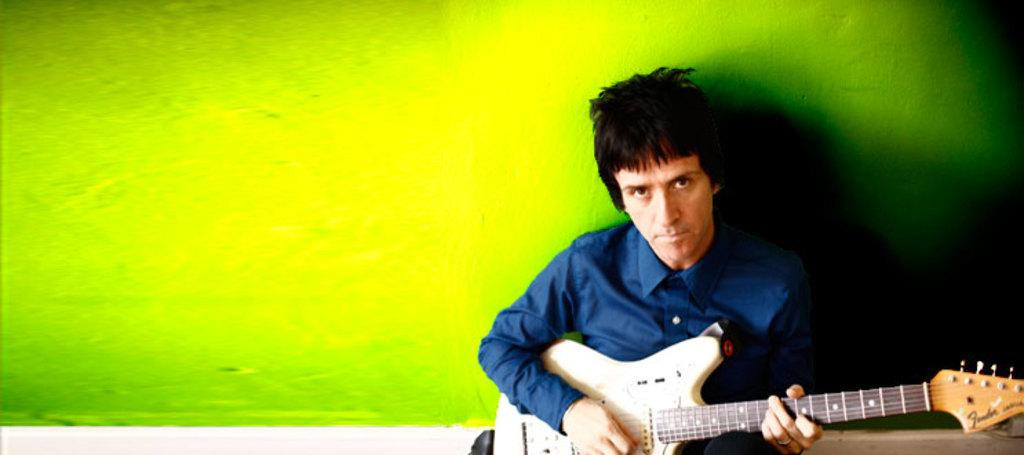What is the man in the image holding? The man is holding a guitar. What is the man wearing in the image? The man is wearing a blue shirt. What type of crate is the man using to store his rewards and profits in the image? There is no crate, rewards, or profits present in the image. 